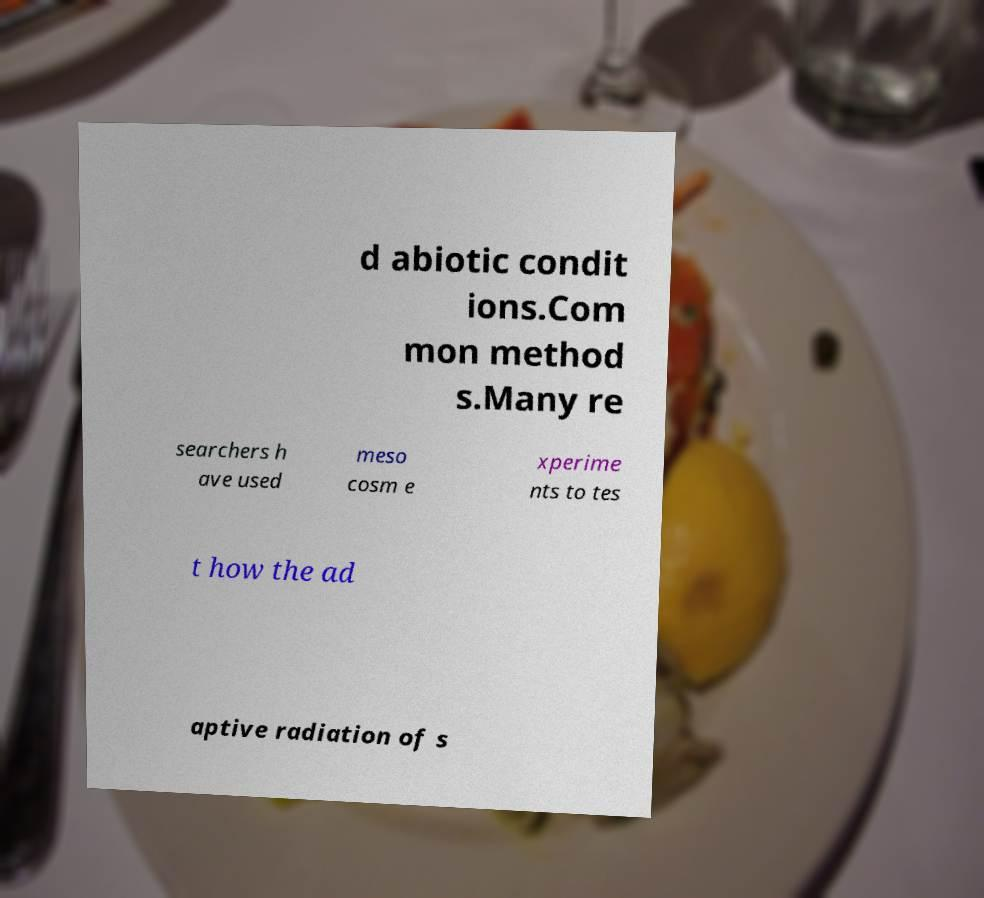What messages or text are displayed in this image? I need them in a readable, typed format. d abiotic condit ions.Com mon method s.Many re searchers h ave used meso cosm e xperime nts to tes t how the ad aptive radiation of s 